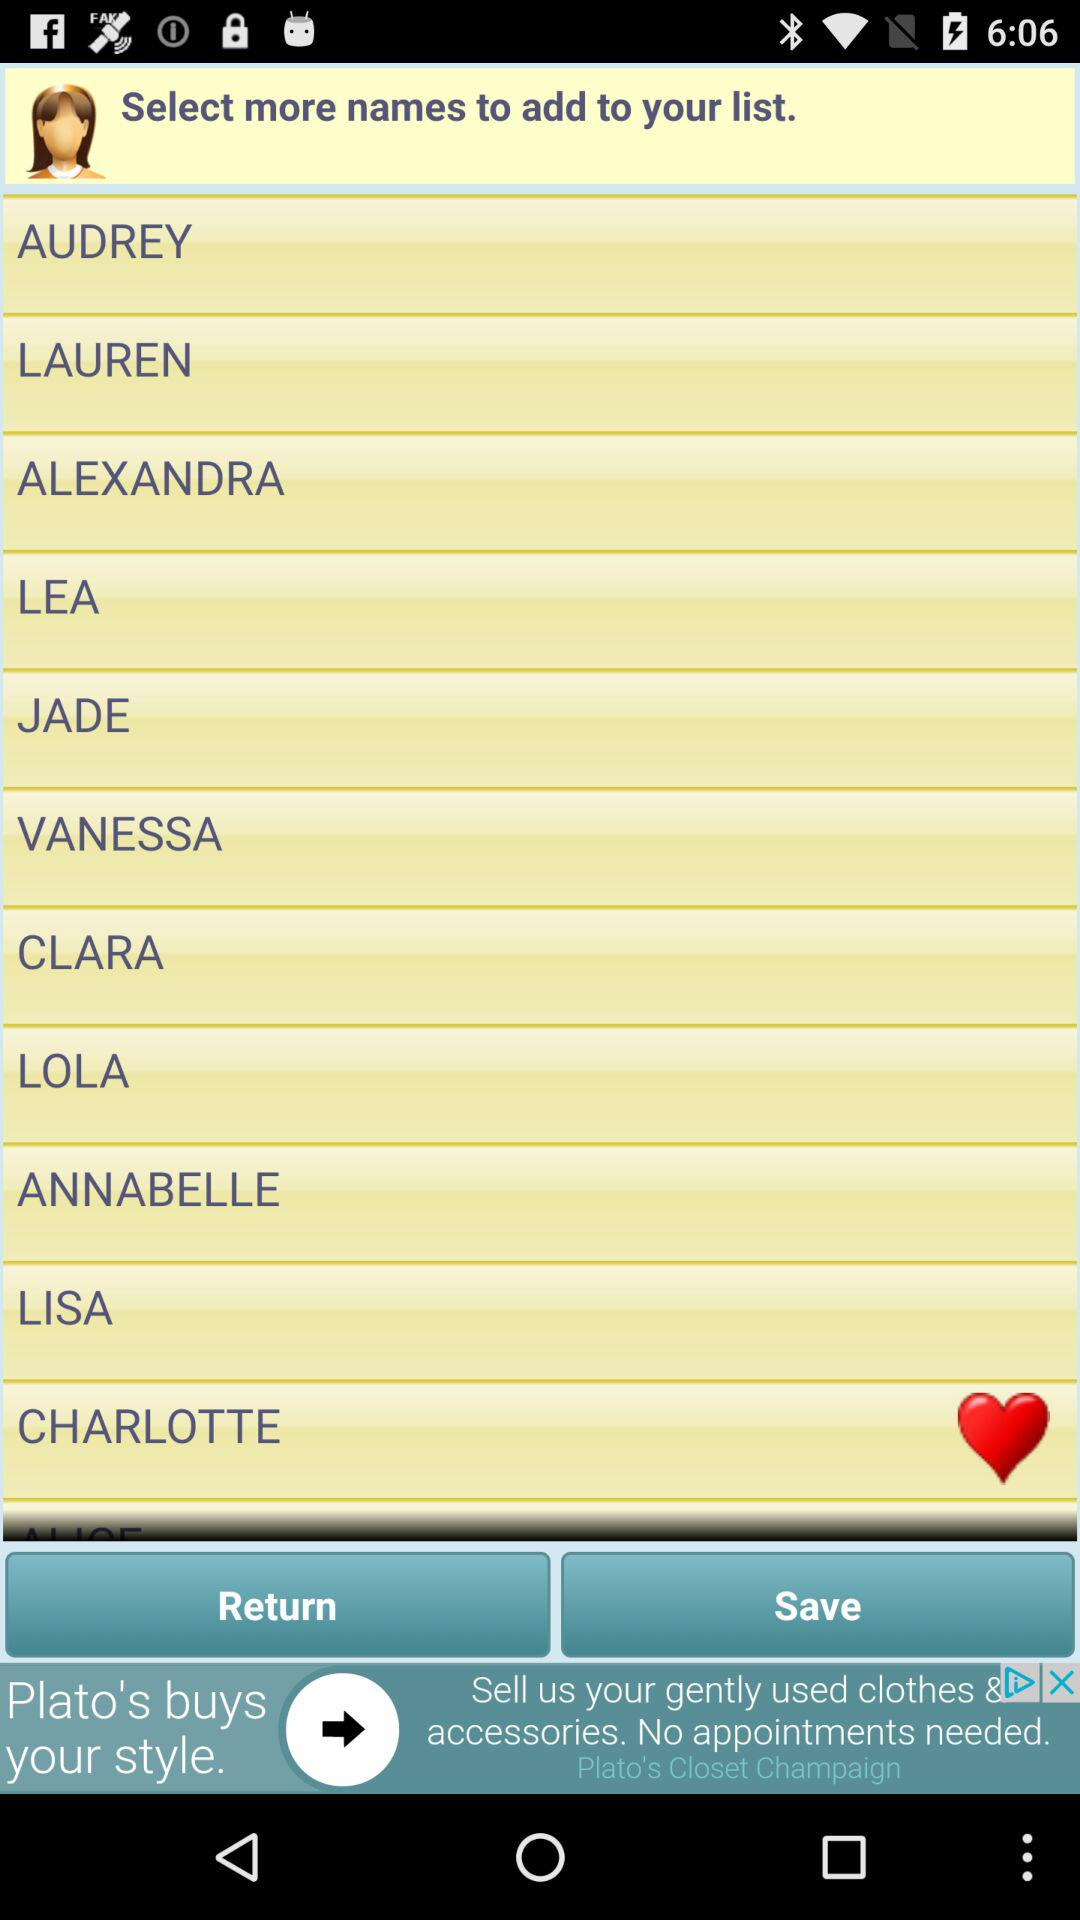Are there any interactive elements visible on this screen that indicate user engagement features? Yes, there are several interactive elements visible. There's a 'Save' button at the bottom, suggesting that users can save their choices. Additionally, a heart icon at the top right corner may allow users to favorite or like certain items or categories. The presence of advertisements at the bottom also indicates commercial activity, perhaps linking to offers or products relevant to user interests. 